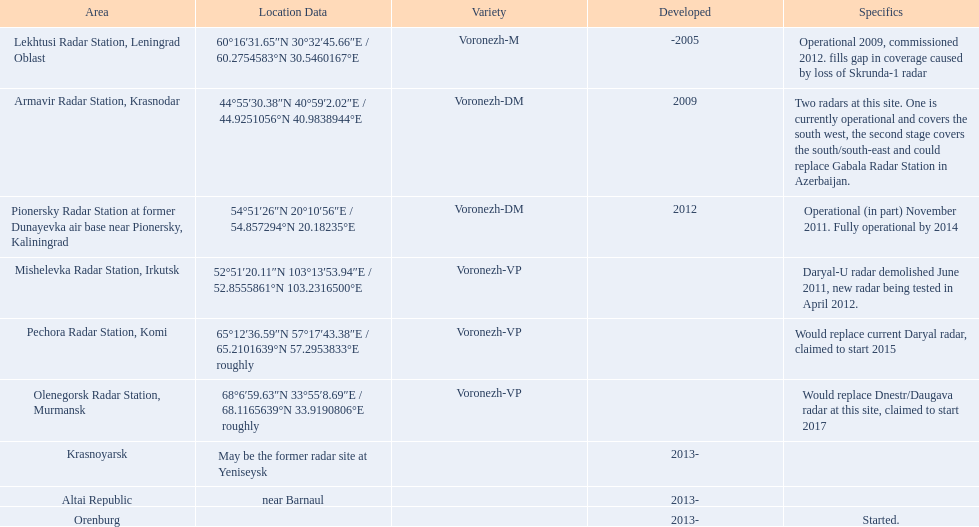What are the list of radar locations? Lekhtusi Radar Station, Leningrad Oblast, Armavir Radar Station, Krasnodar, Pionersky Radar Station at former Dunayevka air base near Pionersky, Kaliningrad, Mishelevka Radar Station, Irkutsk, Pechora Radar Station, Komi, Olenegorsk Radar Station, Murmansk, Krasnoyarsk, Altai Republic, Orenburg. Which of these are claimed to start in 2015? Pechora Radar Station, Komi. 